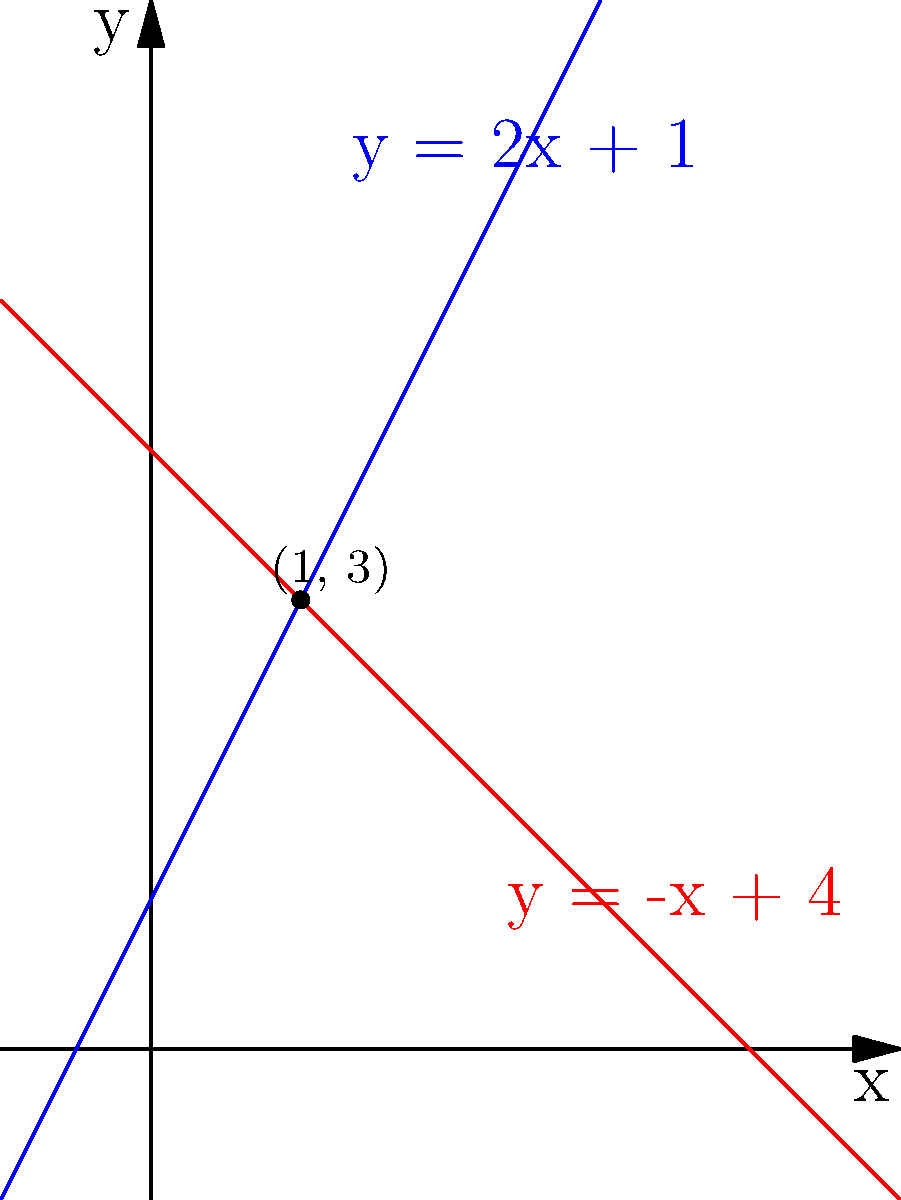Given two lines in a 2D plane with equations $y = 2x + 1$ and $y = -x + 4$, determine their intersection point. Round your answer to the nearest integer if necessary. To find the intersection point of two lines, we need to solve the system of equations:

1) $y = 2x + 1$ (Line 1)
2) $y = -x + 4$ (Line 2)

At the intersection point, the y-values are equal, so we can set the right sides of the equations equal to each other:

3) $2x + 1 = -x + 4$

Now, let's solve for x:

4) $2x + x = 4 - 1$
5) $3x = 3$
6) $x = 1$

To find y, we can substitute x = 1 into either of the original equations. Let's use the first one:

7) $y = 2(1) + 1 = 2 + 1 = 3$

Therefore, the intersection point is (1, 3).
Answer: (1, 3) 